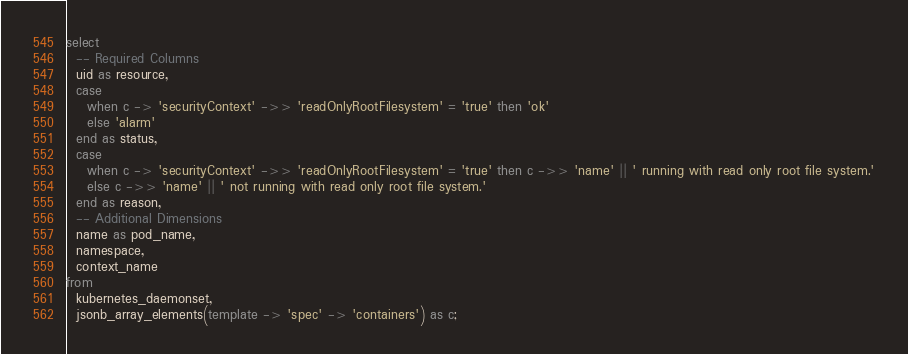<code> <loc_0><loc_0><loc_500><loc_500><_SQL_>select
  -- Required Columns
  uid as resource,
  case
    when c -> 'securityContext' ->> 'readOnlyRootFilesystem' = 'true' then 'ok'
    else 'alarm'
  end as status,
  case
    when c -> 'securityContext' ->> 'readOnlyRootFilesystem' = 'true' then c ->> 'name' || ' running with read only root file system.'
    else c ->> 'name' || ' not running with read only root file system.'
  end as reason,
  -- Additional Dimensions
  name as pod_name,
  namespace,
  context_name
from
  kubernetes_daemonset,
  jsonb_array_elements(template -> 'spec' -> 'containers') as c;</code> 